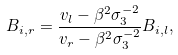Convert formula to latex. <formula><loc_0><loc_0><loc_500><loc_500>B _ { i , r } = \frac { v _ { l } - \beta ^ { 2 } \sigma _ { 3 } ^ { - 2 } } { v _ { r } - \beta ^ { 2 } \sigma _ { 3 } ^ { - 2 } } B _ { i , l } ,</formula> 